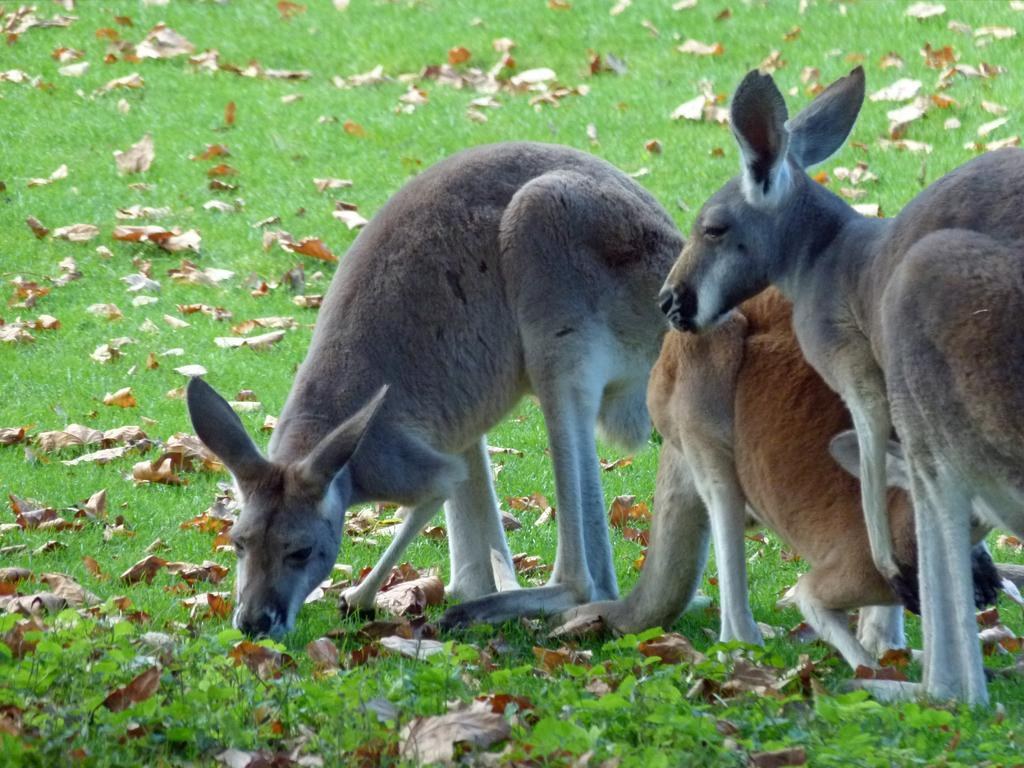What type of living organisms can be seen in the image? There are animals in the image. What are the animals doing in the image? The animals are eating grass. What type of print can be seen on the animals' fur in the image? There is no mention of any print on the animals' fur in the image. 